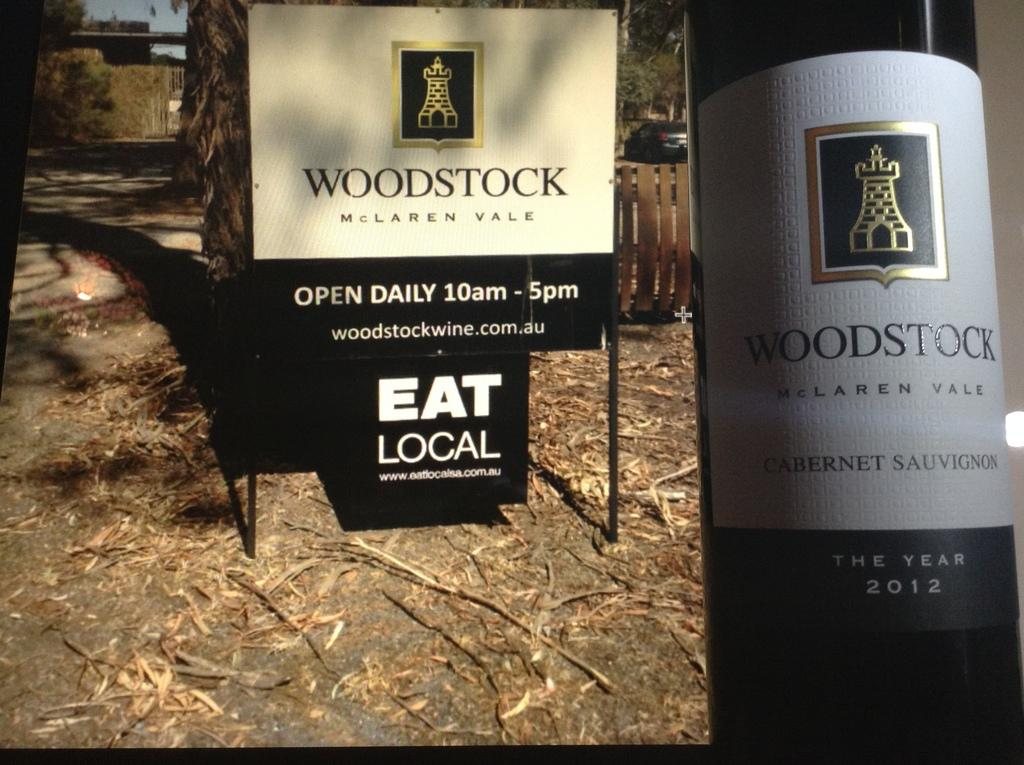<image>
Give a short and clear explanation of the subsequent image. A sign for Woodstock Mclaren Vale telling people they should eat local 